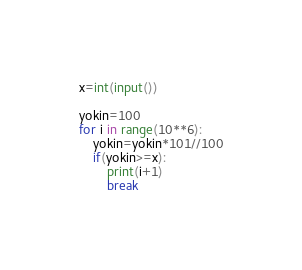<code> <loc_0><loc_0><loc_500><loc_500><_Python_>x=int(input())

yokin=100
for i in range(10**6):
    yokin=yokin*101//100
    if(yokin>=x):
        print(i+1)
        break</code> 